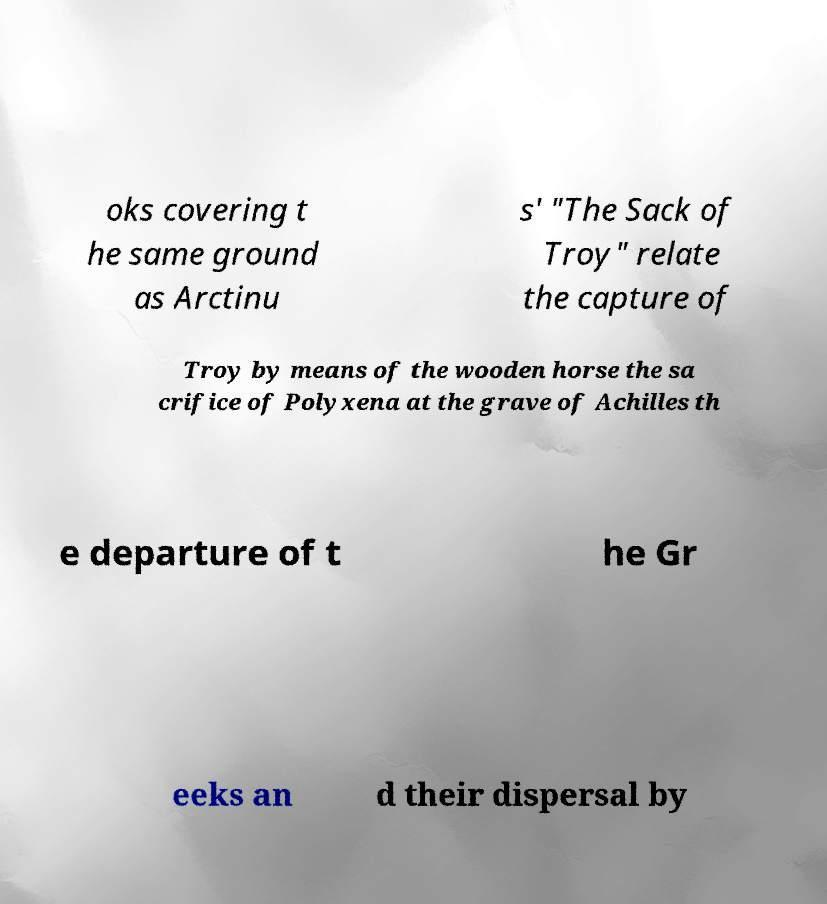What messages or text are displayed in this image? I need them in a readable, typed format. oks covering t he same ground as Arctinu s' "The Sack of Troy" relate the capture of Troy by means of the wooden horse the sa crifice of Polyxena at the grave of Achilles th e departure of t he Gr eeks an d their dispersal by 